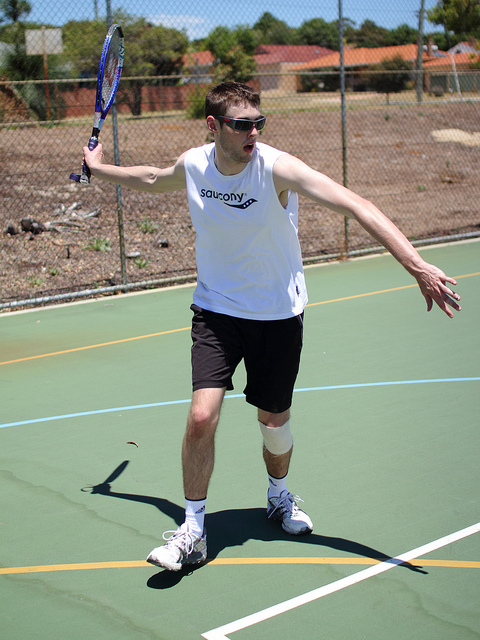Extract all visible text content from this image. saucony S 